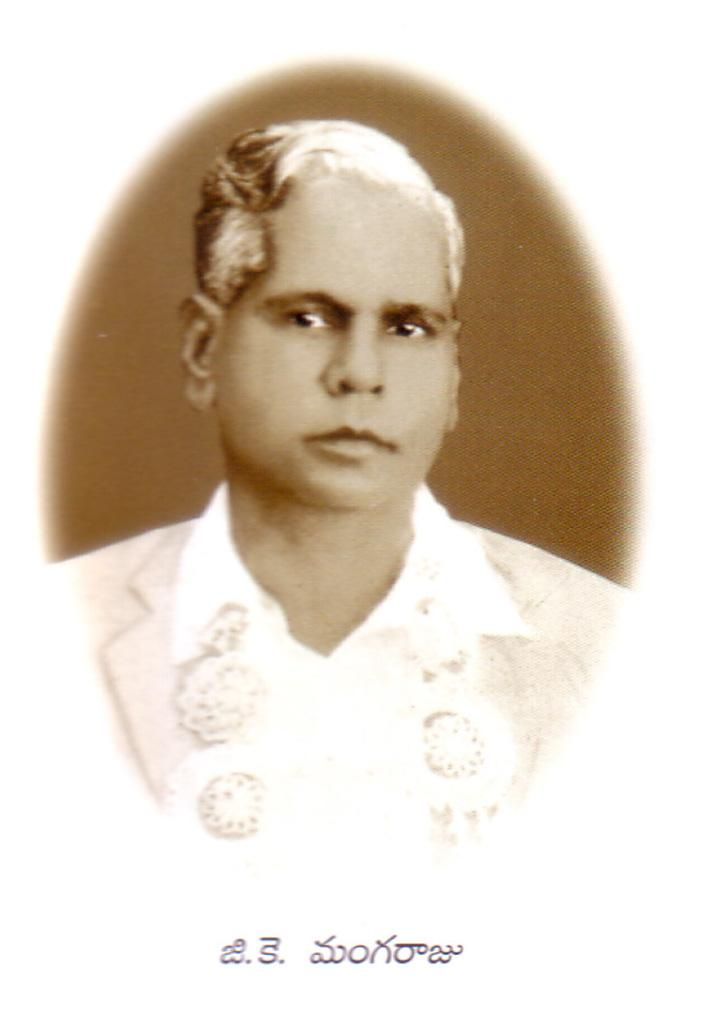What is the main subject of the image? There is a photo of a man in the image. What else can be seen at the bottom of the image? There is text at the bottom of the image. What color is the background of the image? The background of the image is white. Can you describe the garden in the image? There is no garden present in the image; it features a photo of a man with text at the bottom and a white background. What type of church is depicted in the image? There is no church present in the image. 